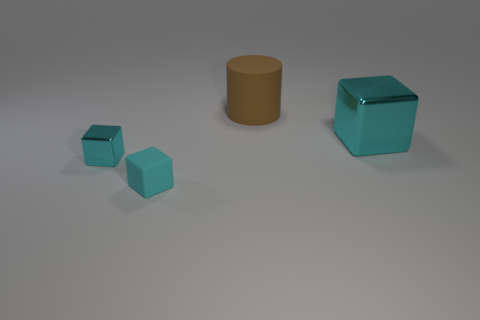Subtract all cyan blocks. How many were subtracted if there are1cyan blocks left? 2 Add 3 large cyan metal blocks. How many objects exist? 7 Subtract all cylinders. How many objects are left? 3 Subtract all cyan blocks. Subtract all big rubber cylinders. How many objects are left? 0 Add 4 cyan things. How many cyan things are left? 7 Add 2 large shiny blocks. How many large shiny blocks exist? 3 Subtract 0 gray blocks. How many objects are left? 4 